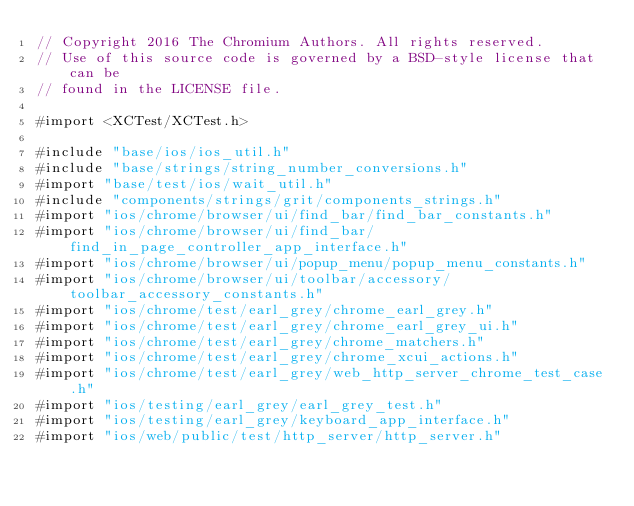Convert code to text. <code><loc_0><loc_0><loc_500><loc_500><_ObjectiveC_>// Copyright 2016 The Chromium Authors. All rights reserved.
// Use of this source code is governed by a BSD-style license that can be
// found in the LICENSE file.

#import <XCTest/XCTest.h>

#include "base/ios/ios_util.h"
#include "base/strings/string_number_conversions.h"
#import "base/test/ios/wait_util.h"
#include "components/strings/grit/components_strings.h"
#import "ios/chrome/browser/ui/find_bar/find_bar_constants.h"
#import "ios/chrome/browser/ui/find_bar/find_in_page_controller_app_interface.h"
#import "ios/chrome/browser/ui/popup_menu/popup_menu_constants.h"
#import "ios/chrome/browser/ui/toolbar/accessory/toolbar_accessory_constants.h"
#import "ios/chrome/test/earl_grey/chrome_earl_grey.h"
#import "ios/chrome/test/earl_grey/chrome_earl_grey_ui.h"
#import "ios/chrome/test/earl_grey/chrome_matchers.h"
#import "ios/chrome/test/earl_grey/chrome_xcui_actions.h"
#import "ios/chrome/test/earl_grey/web_http_server_chrome_test_case.h"
#import "ios/testing/earl_grey/earl_grey_test.h"
#import "ios/testing/earl_grey/keyboard_app_interface.h"
#import "ios/web/public/test/http_server/http_server.h"</code> 